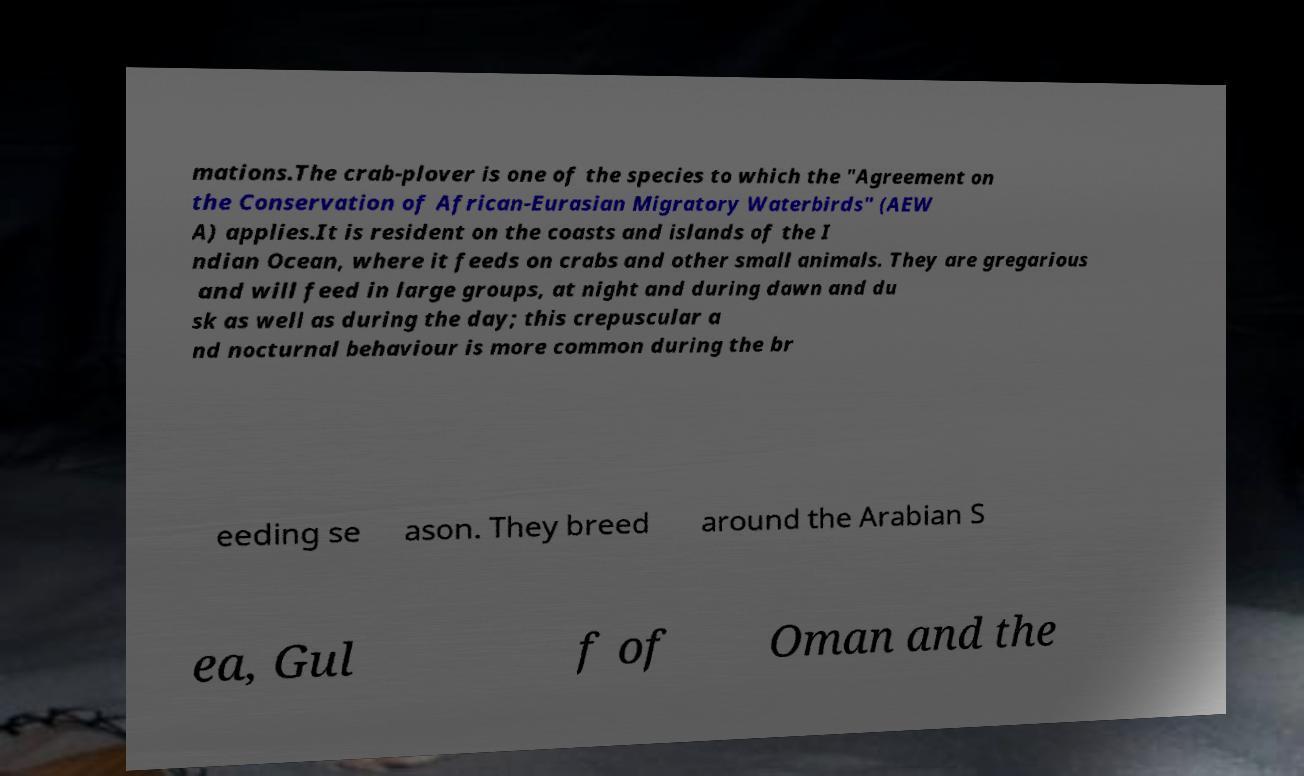Could you extract and type out the text from this image? mations.The crab-plover is one of the species to which the "Agreement on the Conservation of African-Eurasian Migratory Waterbirds" (AEW A) applies.It is resident on the coasts and islands of the I ndian Ocean, where it feeds on crabs and other small animals. They are gregarious and will feed in large groups, at night and during dawn and du sk as well as during the day; this crepuscular a nd nocturnal behaviour is more common during the br eeding se ason. They breed around the Arabian S ea, Gul f of Oman and the 